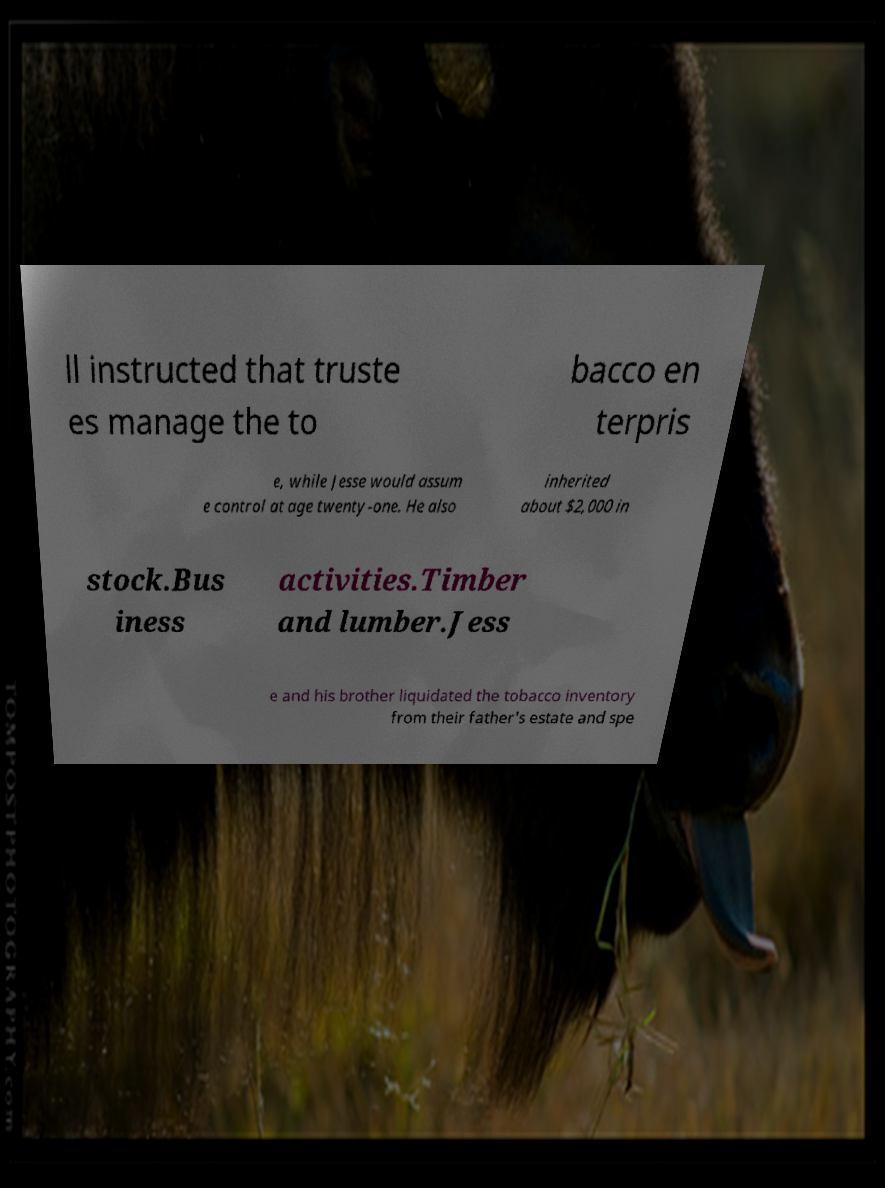Could you extract and type out the text from this image? ll instructed that truste es manage the to bacco en terpris e, while Jesse would assum e control at age twenty-one. He also inherited about $2,000 in stock.Bus iness activities.Timber and lumber.Jess e and his brother liquidated the tobacco inventory from their father's estate and spe 